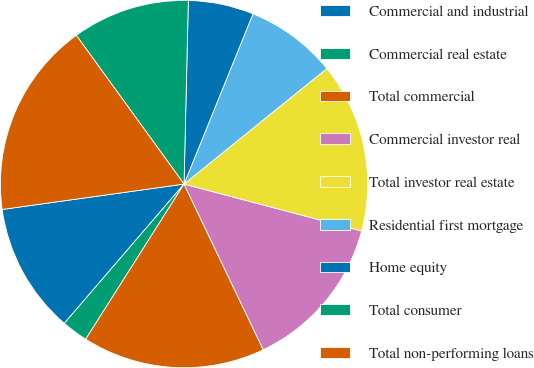Convert chart to OTSL. <chart><loc_0><loc_0><loc_500><loc_500><pie_chart><fcel>Commercial and industrial<fcel>Commercial real estate<fcel>Total commercial<fcel>Commercial investor real<fcel>Total investor real estate<fcel>Residential first mortgage<fcel>Home equity<fcel>Total consumer<fcel>Total non-performing loans<nl><fcel>11.49%<fcel>2.31%<fcel>16.09%<fcel>13.79%<fcel>14.94%<fcel>8.05%<fcel>5.75%<fcel>10.35%<fcel>17.23%<nl></chart> 